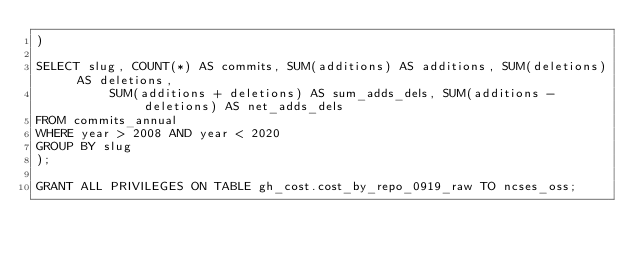<code> <loc_0><loc_0><loc_500><loc_500><_SQL_>)

SELECT slug, COUNT(*) AS commits, SUM(additions) AS additions, SUM(deletions) AS deletions,
					SUM(additions + deletions) AS sum_adds_dels, SUM(additions - deletions) AS net_adds_dels
FROM commits_annual
WHERE year > 2008 AND year < 2020
GROUP BY slug
);

GRANT ALL PRIVILEGES ON TABLE gh_cost.cost_by_repo_0919_raw TO ncses_oss;
</code> 